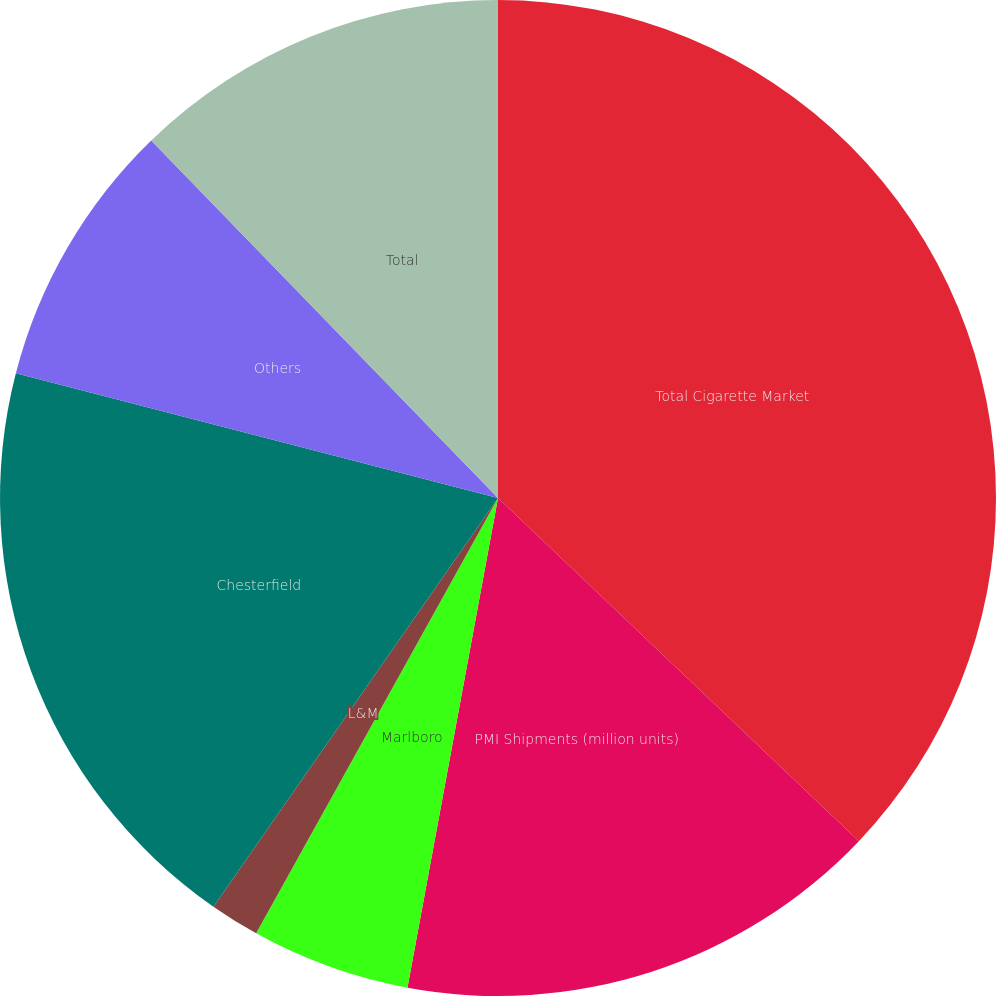Convert chart. <chart><loc_0><loc_0><loc_500><loc_500><pie_chart><fcel>Total Cigarette Market<fcel>PMI Shipments (million units)<fcel>Marlboro<fcel>L&M<fcel>Chesterfield<fcel>Others<fcel>Total<nl><fcel>37.1%<fcel>15.81%<fcel>5.16%<fcel>1.61%<fcel>19.35%<fcel>8.71%<fcel>12.26%<nl></chart> 